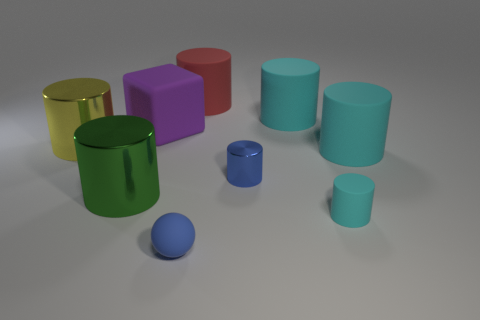Subtract all blue shiny cylinders. How many cylinders are left? 6 Subtract all balls. How many objects are left? 8 Add 1 tiny matte spheres. How many objects exist? 10 Subtract all brown things. Subtract all tiny blue spheres. How many objects are left? 8 Add 2 big purple things. How many big purple things are left? 3 Add 8 purple rubber cubes. How many purple rubber cubes exist? 9 Subtract all red cylinders. How many cylinders are left? 6 Subtract 1 purple cubes. How many objects are left? 8 Subtract 1 balls. How many balls are left? 0 Subtract all gray balls. Subtract all purple cylinders. How many balls are left? 1 